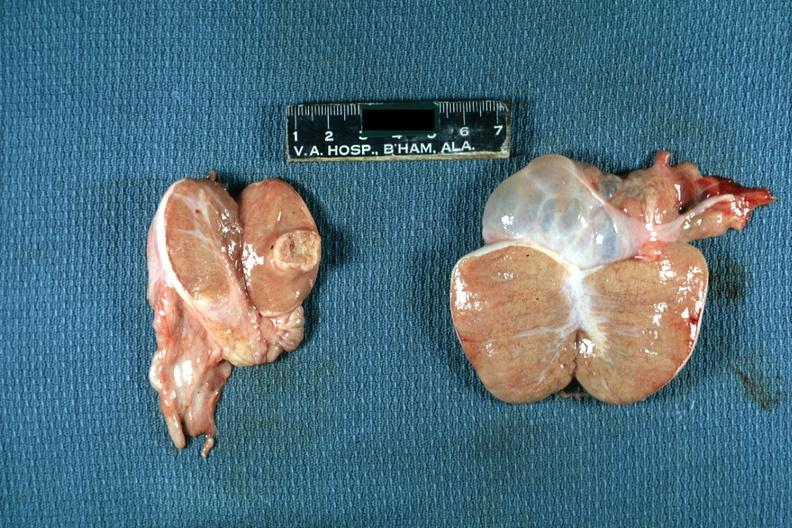what is present?
Answer the question using a single word or phrase. Interstitial cell tumor 